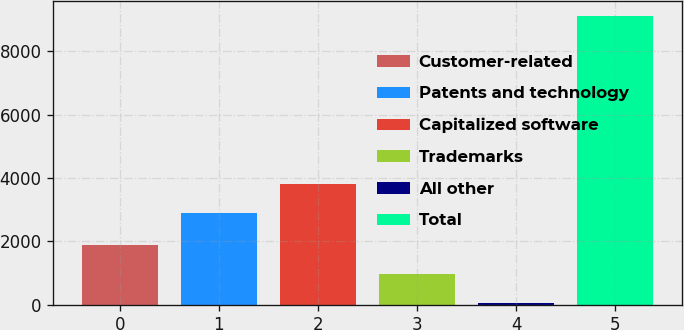<chart> <loc_0><loc_0><loc_500><loc_500><bar_chart><fcel>Customer-related<fcel>Patents and technology<fcel>Capitalized software<fcel>Trademarks<fcel>All other<fcel>Total<nl><fcel>1868.6<fcel>2894<fcel>3801.8<fcel>960.8<fcel>53<fcel>9131<nl></chart> 